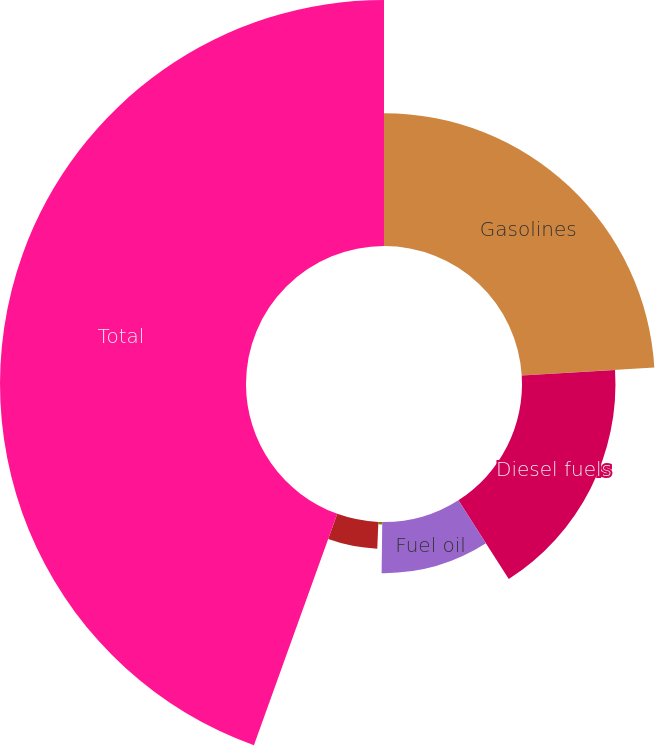Convert chart. <chart><loc_0><loc_0><loc_500><loc_500><pie_chart><fcel>Gasolines<fcel>Diesel fuels<fcel>Fuel oil<fcel>Asphalt<fcel>LPG and other<fcel>Total<nl><fcel>24.03%<fcel>16.91%<fcel>9.26%<fcel>0.45%<fcel>4.85%<fcel>44.5%<nl></chart> 